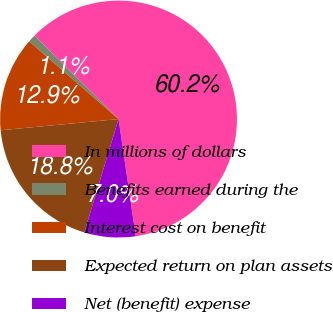<chart> <loc_0><loc_0><loc_500><loc_500><pie_chart><fcel>In millions of dollars<fcel>Benefits earned during the<fcel>Interest cost on benefit<fcel>Expected return on plan assets<fcel>Net (benefit) expense<nl><fcel>60.21%<fcel>1.08%<fcel>12.9%<fcel>18.82%<fcel>6.99%<nl></chart> 